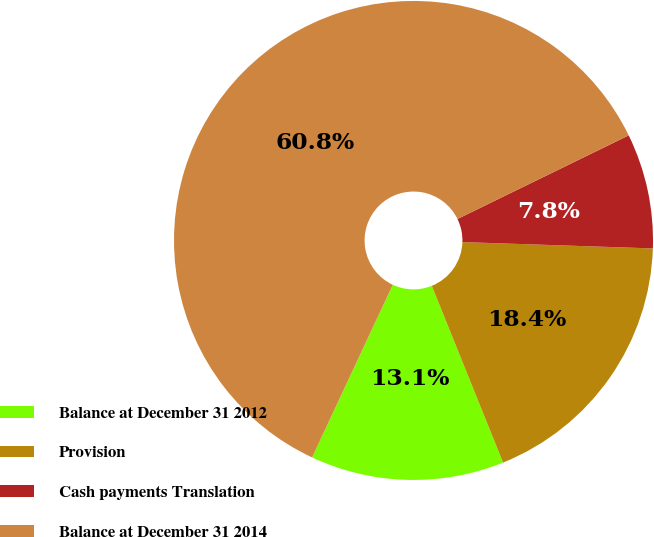<chart> <loc_0><loc_0><loc_500><loc_500><pie_chart><fcel>Balance at December 31 2012<fcel>Provision<fcel>Cash payments Translation<fcel>Balance at December 31 2014<nl><fcel>13.06%<fcel>18.37%<fcel>7.76%<fcel>60.81%<nl></chart> 